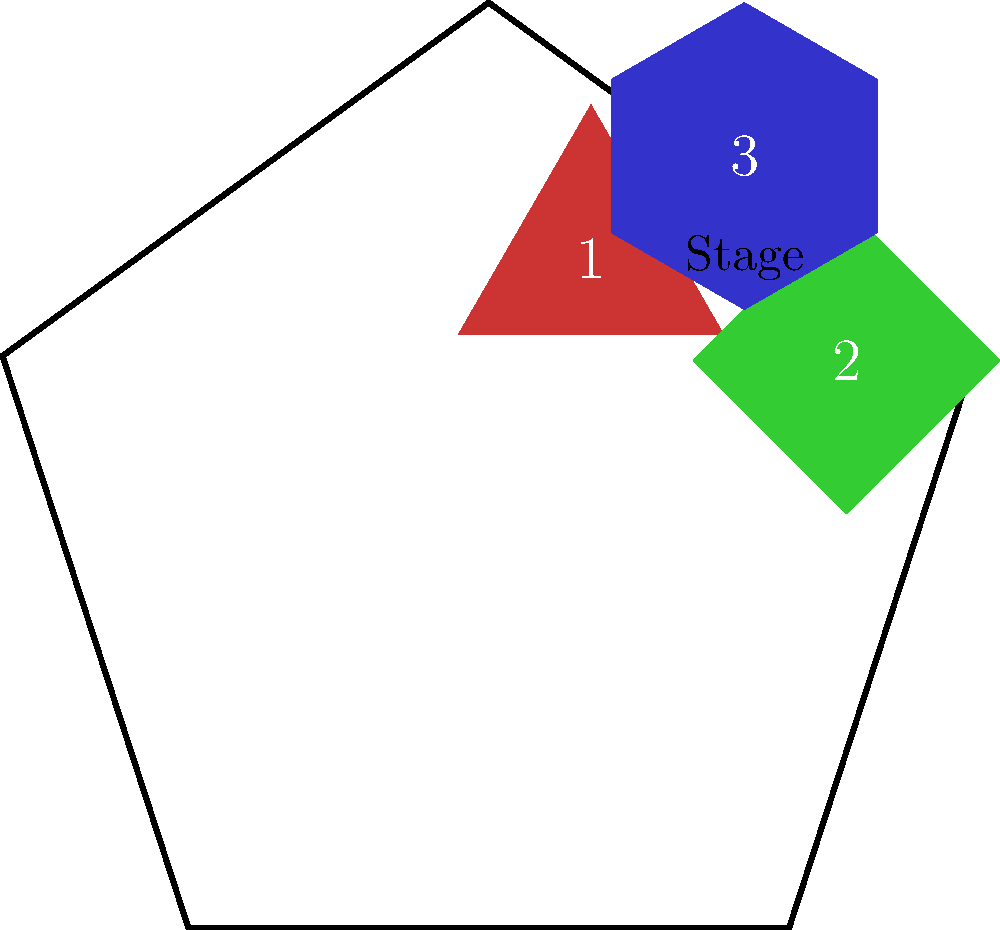In the stage design above, which set piece would need to be rotated approximately 90 degrees clockwise to fit flush against the bottom edge of the stage? To solve this problem, we need to mentally rotate each piece and consider how it would fit against the bottom edge of the stage:

1. Piece 1 (red triangle): This piece is already oriented with a flat edge parallel to the bottom of the stage. Rotating it 90 degrees would not improve its fit.

2. Piece 2 (green square): This piece is currently rotated at a 45-degree angle. If we rotate it 90 degrees clockwise from its current position, it would end up with a flat edge parallel to the bottom of the stage, fitting flush against it.

3. Piece 3 (blue hexagon): This piece is slightly rotated counterclockwise. A 90-degree clockwise rotation would not result in a flat edge parallel to the bottom of the stage.

Therefore, Piece 2 (the green square) is the only piece that would fit flush against the bottom edge of the stage after a 90-degree clockwise rotation.
Answer: Piece 2 (green square) 